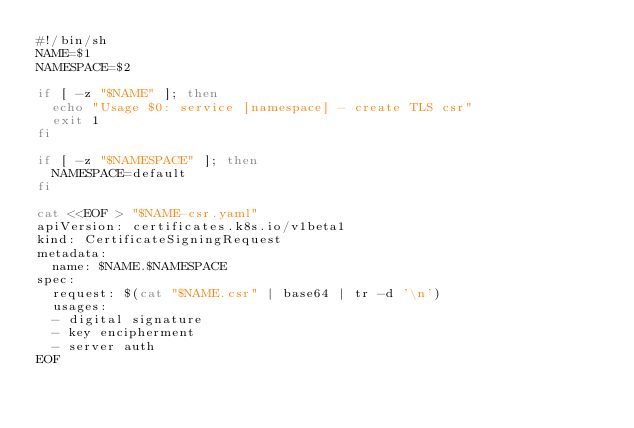<code> <loc_0><loc_0><loc_500><loc_500><_Bash_>#!/bin/sh
NAME=$1
NAMESPACE=$2

if [ -z "$NAME" ]; then
  echo "Usage $0: service [namespace] - create TLS csr"
  exit 1
fi

if [ -z "$NAMESPACE" ]; then
  NAMESPACE=default
fi

cat <<EOF > "$NAME-csr.yaml"
apiVersion: certificates.k8s.io/v1beta1
kind: CertificateSigningRequest
metadata:
  name: $NAME.$NAMESPACE
spec:
  request: $(cat "$NAME.csr" | base64 | tr -d '\n')
  usages:
  - digital signature
  - key encipherment
  - server auth
EOF
</code> 